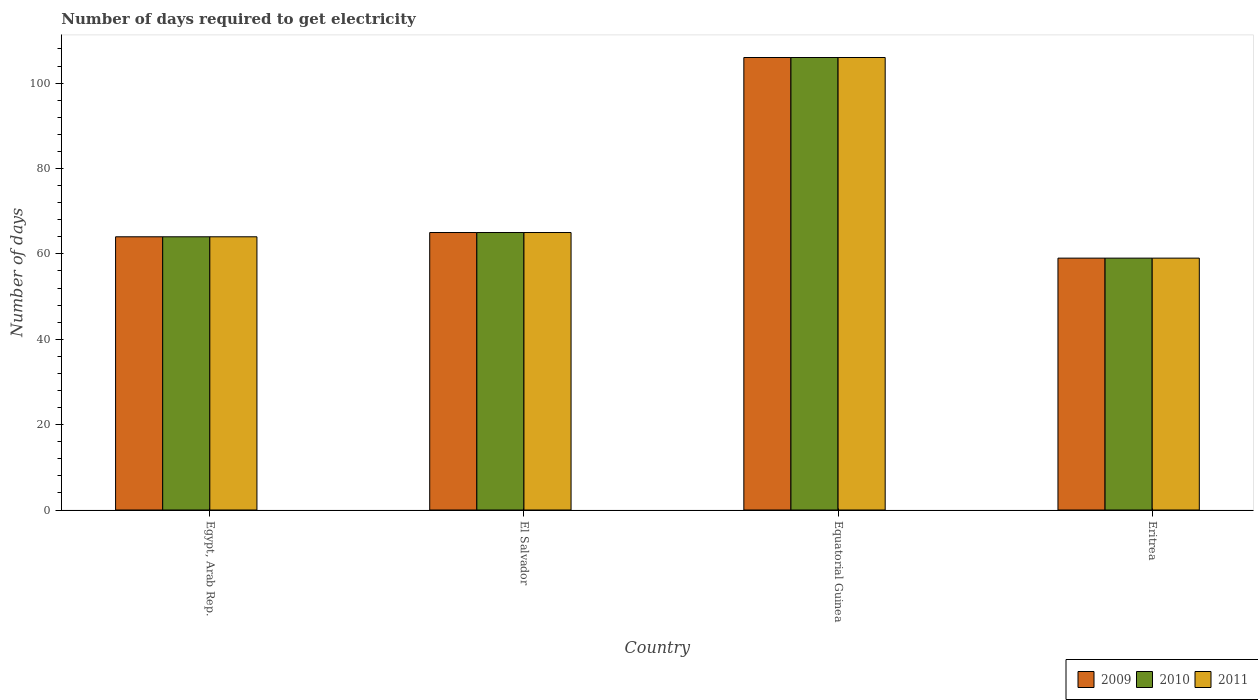How many different coloured bars are there?
Offer a very short reply. 3. How many groups of bars are there?
Your response must be concise. 4. Are the number of bars per tick equal to the number of legend labels?
Offer a terse response. Yes. How many bars are there on the 1st tick from the left?
Your answer should be compact. 3. How many bars are there on the 3rd tick from the right?
Your answer should be compact. 3. What is the label of the 1st group of bars from the left?
Give a very brief answer. Egypt, Arab Rep. What is the number of days required to get electricity in in 2011 in Equatorial Guinea?
Your answer should be very brief. 106. Across all countries, what is the maximum number of days required to get electricity in in 2010?
Offer a terse response. 106. Across all countries, what is the minimum number of days required to get electricity in in 2009?
Provide a succinct answer. 59. In which country was the number of days required to get electricity in in 2011 maximum?
Provide a short and direct response. Equatorial Guinea. In which country was the number of days required to get electricity in in 2010 minimum?
Offer a terse response. Eritrea. What is the total number of days required to get electricity in in 2009 in the graph?
Your answer should be very brief. 294. What is the difference between the number of days required to get electricity in in 2009 in Egypt, Arab Rep. and that in Equatorial Guinea?
Make the answer very short. -42. What is the difference between the number of days required to get electricity in in 2009 in El Salvador and the number of days required to get electricity in in 2010 in Eritrea?
Ensure brevity in your answer.  6. What is the average number of days required to get electricity in in 2009 per country?
Offer a very short reply. 73.5. In how many countries, is the number of days required to get electricity in in 2011 greater than 40 days?
Offer a terse response. 4. What is the ratio of the number of days required to get electricity in in 2009 in Equatorial Guinea to that in Eritrea?
Your answer should be very brief. 1.8. Is the difference between the number of days required to get electricity in in 2011 in Equatorial Guinea and Eritrea greater than the difference between the number of days required to get electricity in in 2010 in Equatorial Guinea and Eritrea?
Make the answer very short. No. What is the difference between the highest and the second highest number of days required to get electricity in in 2010?
Offer a very short reply. -1. What is the difference between the highest and the lowest number of days required to get electricity in in 2010?
Give a very brief answer. 47. Is the sum of the number of days required to get electricity in in 2011 in Egypt, Arab Rep. and El Salvador greater than the maximum number of days required to get electricity in in 2009 across all countries?
Your answer should be compact. Yes. What does the 2nd bar from the left in El Salvador represents?
Your response must be concise. 2010. How many bars are there?
Your response must be concise. 12. Are all the bars in the graph horizontal?
Keep it short and to the point. No. What is the difference between two consecutive major ticks on the Y-axis?
Your answer should be compact. 20. Are the values on the major ticks of Y-axis written in scientific E-notation?
Your response must be concise. No. Does the graph contain any zero values?
Make the answer very short. No. Does the graph contain grids?
Keep it short and to the point. No. How many legend labels are there?
Your answer should be very brief. 3. How are the legend labels stacked?
Keep it short and to the point. Horizontal. What is the title of the graph?
Your answer should be compact. Number of days required to get electricity. Does "1972" appear as one of the legend labels in the graph?
Provide a short and direct response. No. What is the label or title of the X-axis?
Make the answer very short. Country. What is the label or title of the Y-axis?
Ensure brevity in your answer.  Number of days. What is the Number of days of 2010 in Egypt, Arab Rep.?
Your response must be concise. 64. What is the Number of days in 2011 in Egypt, Arab Rep.?
Keep it short and to the point. 64. What is the Number of days in 2011 in El Salvador?
Your answer should be very brief. 65. What is the Number of days of 2009 in Equatorial Guinea?
Offer a terse response. 106. What is the Number of days in 2010 in Equatorial Guinea?
Your answer should be very brief. 106. What is the Number of days of 2011 in Equatorial Guinea?
Offer a terse response. 106. What is the Number of days of 2010 in Eritrea?
Give a very brief answer. 59. What is the Number of days in 2011 in Eritrea?
Offer a terse response. 59. Across all countries, what is the maximum Number of days of 2009?
Keep it short and to the point. 106. Across all countries, what is the maximum Number of days of 2010?
Your response must be concise. 106. Across all countries, what is the maximum Number of days in 2011?
Provide a succinct answer. 106. Across all countries, what is the minimum Number of days of 2009?
Your answer should be compact. 59. Across all countries, what is the minimum Number of days of 2011?
Offer a very short reply. 59. What is the total Number of days in 2009 in the graph?
Provide a succinct answer. 294. What is the total Number of days of 2010 in the graph?
Keep it short and to the point. 294. What is the total Number of days of 2011 in the graph?
Ensure brevity in your answer.  294. What is the difference between the Number of days in 2009 in Egypt, Arab Rep. and that in El Salvador?
Your answer should be compact. -1. What is the difference between the Number of days in 2010 in Egypt, Arab Rep. and that in El Salvador?
Your answer should be compact. -1. What is the difference between the Number of days of 2009 in Egypt, Arab Rep. and that in Equatorial Guinea?
Your response must be concise. -42. What is the difference between the Number of days of 2010 in Egypt, Arab Rep. and that in Equatorial Guinea?
Provide a succinct answer. -42. What is the difference between the Number of days in 2011 in Egypt, Arab Rep. and that in Equatorial Guinea?
Provide a short and direct response. -42. What is the difference between the Number of days in 2011 in Egypt, Arab Rep. and that in Eritrea?
Provide a succinct answer. 5. What is the difference between the Number of days of 2009 in El Salvador and that in Equatorial Guinea?
Your response must be concise. -41. What is the difference between the Number of days in 2010 in El Salvador and that in Equatorial Guinea?
Offer a terse response. -41. What is the difference between the Number of days of 2011 in El Salvador and that in Equatorial Guinea?
Give a very brief answer. -41. What is the difference between the Number of days of 2009 in El Salvador and that in Eritrea?
Keep it short and to the point. 6. What is the difference between the Number of days of 2011 in El Salvador and that in Eritrea?
Give a very brief answer. 6. What is the difference between the Number of days of 2009 in Equatorial Guinea and that in Eritrea?
Offer a very short reply. 47. What is the difference between the Number of days of 2009 in Egypt, Arab Rep. and the Number of days of 2010 in El Salvador?
Give a very brief answer. -1. What is the difference between the Number of days in 2009 in Egypt, Arab Rep. and the Number of days in 2011 in El Salvador?
Your answer should be compact. -1. What is the difference between the Number of days in 2009 in Egypt, Arab Rep. and the Number of days in 2010 in Equatorial Guinea?
Your answer should be very brief. -42. What is the difference between the Number of days of 2009 in Egypt, Arab Rep. and the Number of days of 2011 in Equatorial Guinea?
Your response must be concise. -42. What is the difference between the Number of days of 2010 in Egypt, Arab Rep. and the Number of days of 2011 in Equatorial Guinea?
Give a very brief answer. -42. What is the difference between the Number of days of 2009 in Egypt, Arab Rep. and the Number of days of 2010 in Eritrea?
Ensure brevity in your answer.  5. What is the difference between the Number of days of 2009 in El Salvador and the Number of days of 2010 in Equatorial Guinea?
Make the answer very short. -41. What is the difference between the Number of days of 2009 in El Salvador and the Number of days of 2011 in Equatorial Guinea?
Ensure brevity in your answer.  -41. What is the difference between the Number of days in 2010 in El Salvador and the Number of days in 2011 in Equatorial Guinea?
Your response must be concise. -41. What is the difference between the Number of days in 2009 in El Salvador and the Number of days in 2010 in Eritrea?
Your response must be concise. 6. What is the difference between the Number of days of 2009 in El Salvador and the Number of days of 2011 in Eritrea?
Your response must be concise. 6. What is the difference between the Number of days in 2009 in Equatorial Guinea and the Number of days in 2010 in Eritrea?
Provide a succinct answer. 47. What is the difference between the Number of days in 2009 in Equatorial Guinea and the Number of days in 2011 in Eritrea?
Your answer should be compact. 47. What is the difference between the Number of days of 2010 in Equatorial Guinea and the Number of days of 2011 in Eritrea?
Offer a very short reply. 47. What is the average Number of days of 2009 per country?
Your answer should be compact. 73.5. What is the average Number of days of 2010 per country?
Your response must be concise. 73.5. What is the average Number of days of 2011 per country?
Keep it short and to the point. 73.5. What is the difference between the Number of days of 2009 and Number of days of 2010 in Egypt, Arab Rep.?
Give a very brief answer. 0. What is the difference between the Number of days in 2010 and Number of days in 2011 in Egypt, Arab Rep.?
Your response must be concise. 0. What is the difference between the Number of days in 2010 and Number of days in 2011 in El Salvador?
Your response must be concise. 0. What is the difference between the Number of days of 2010 and Number of days of 2011 in Equatorial Guinea?
Make the answer very short. 0. What is the difference between the Number of days in 2010 and Number of days in 2011 in Eritrea?
Your answer should be very brief. 0. What is the ratio of the Number of days of 2009 in Egypt, Arab Rep. to that in El Salvador?
Your answer should be compact. 0.98. What is the ratio of the Number of days of 2010 in Egypt, Arab Rep. to that in El Salvador?
Offer a very short reply. 0.98. What is the ratio of the Number of days in 2011 in Egypt, Arab Rep. to that in El Salvador?
Offer a terse response. 0.98. What is the ratio of the Number of days of 2009 in Egypt, Arab Rep. to that in Equatorial Guinea?
Your answer should be compact. 0.6. What is the ratio of the Number of days of 2010 in Egypt, Arab Rep. to that in Equatorial Guinea?
Keep it short and to the point. 0.6. What is the ratio of the Number of days of 2011 in Egypt, Arab Rep. to that in Equatorial Guinea?
Your response must be concise. 0.6. What is the ratio of the Number of days in 2009 in Egypt, Arab Rep. to that in Eritrea?
Offer a very short reply. 1.08. What is the ratio of the Number of days in 2010 in Egypt, Arab Rep. to that in Eritrea?
Make the answer very short. 1.08. What is the ratio of the Number of days of 2011 in Egypt, Arab Rep. to that in Eritrea?
Provide a succinct answer. 1.08. What is the ratio of the Number of days in 2009 in El Salvador to that in Equatorial Guinea?
Your answer should be compact. 0.61. What is the ratio of the Number of days of 2010 in El Salvador to that in Equatorial Guinea?
Your answer should be compact. 0.61. What is the ratio of the Number of days in 2011 in El Salvador to that in Equatorial Guinea?
Offer a very short reply. 0.61. What is the ratio of the Number of days in 2009 in El Salvador to that in Eritrea?
Offer a terse response. 1.1. What is the ratio of the Number of days in 2010 in El Salvador to that in Eritrea?
Give a very brief answer. 1.1. What is the ratio of the Number of days in 2011 in El Salvador to that in Eritrea?
Offer a terse response. 1.1. What is the ratio of the Number of days in 2009 in Equatorial Guinea to that in Eritrea?
Offer a very short reply. 1.8. What is the ratio of the Number of days in 2010 in Equatorial Guinea to that in Eritrea?
Make the answer very short. 1.8. What is the ratio of the Number of days of 2011 in Equatorial Guinea to that in Eritrea?
Your answer should be compact. 1.8. What is the difference between the highest and the lowest Number of days in 2010?
Offer a terse response. 47. 